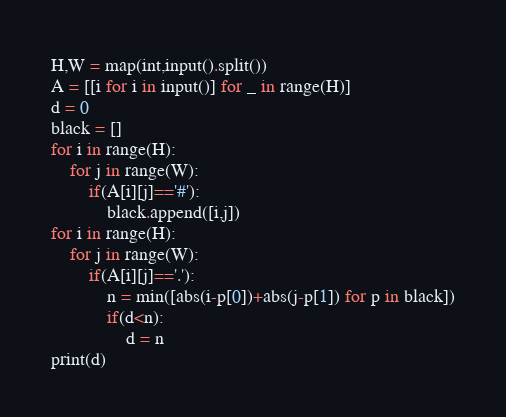Convert code to text. <code><loc_0><loc_0><loc_500><loc_500><_Python_>H,W = map(int,input().split())
A = [[i for i in input()] for _ in range(H)]
d = 0
black = []
for i in range(H):
    for j in range(W):
        if(A[i][j]=='#'):
            black.append([i,j])
for i in range(H):
    for j in range(W):
        if(A[i][j]=='.'):
            n = min([abs(i-p[0])+abs(j-p[1]) for p in black])
            if(d<n):
                d = n
print(d)</code> 